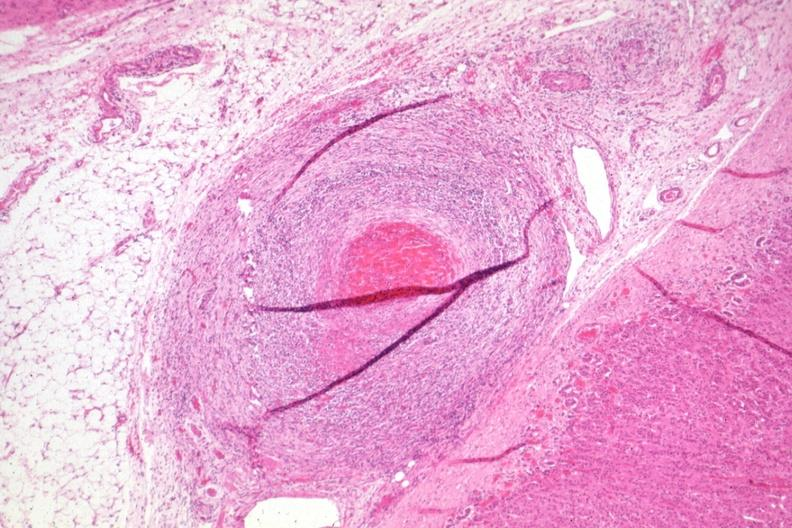what does this image show?
Answer the question using a single word or phrase. Healing lesion in medium size artery just outside adrenal capsule section has folds 